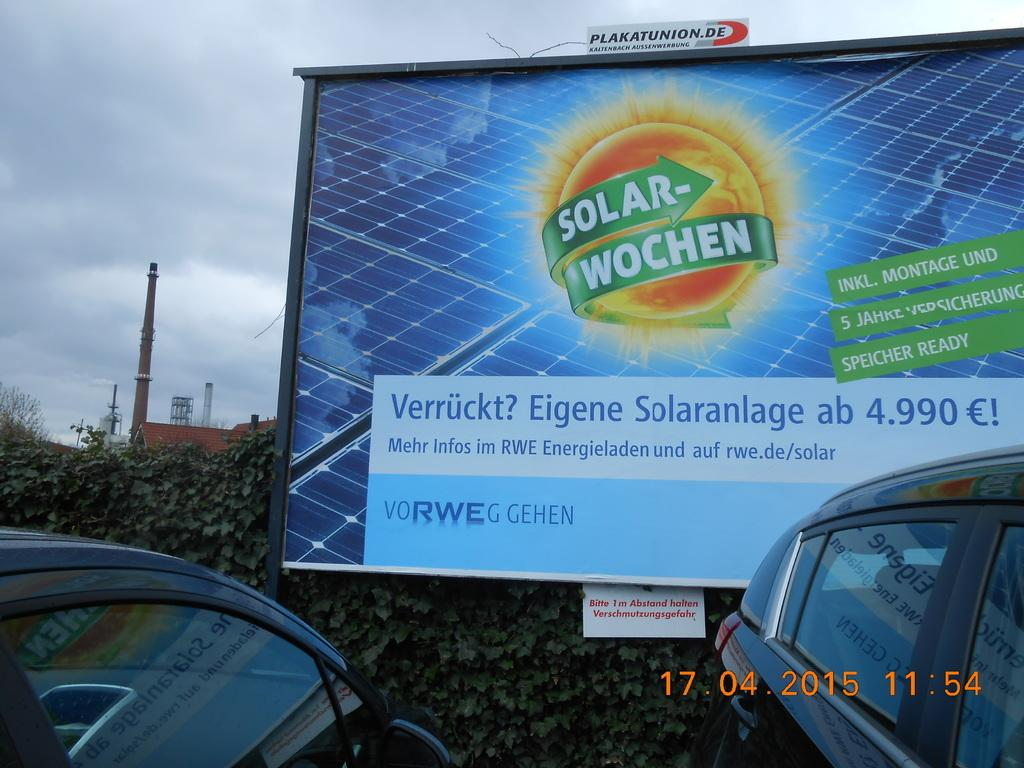What is the main structure visible in the image? There is a hoarding in the image. What type of vehicles can be seen in the image? There are cars in the image. What natural elements are present in the image? There are trees in the image. What type of man-made structure is visible in the image? There is a building in the image. What other objects can be seen in the image? There are poles in the image. What is visible in the background of the image? The sky with clouds is visible in the background of the image. What type of canvas is used to create the line in the image? There is no line or canvas present in the image. 